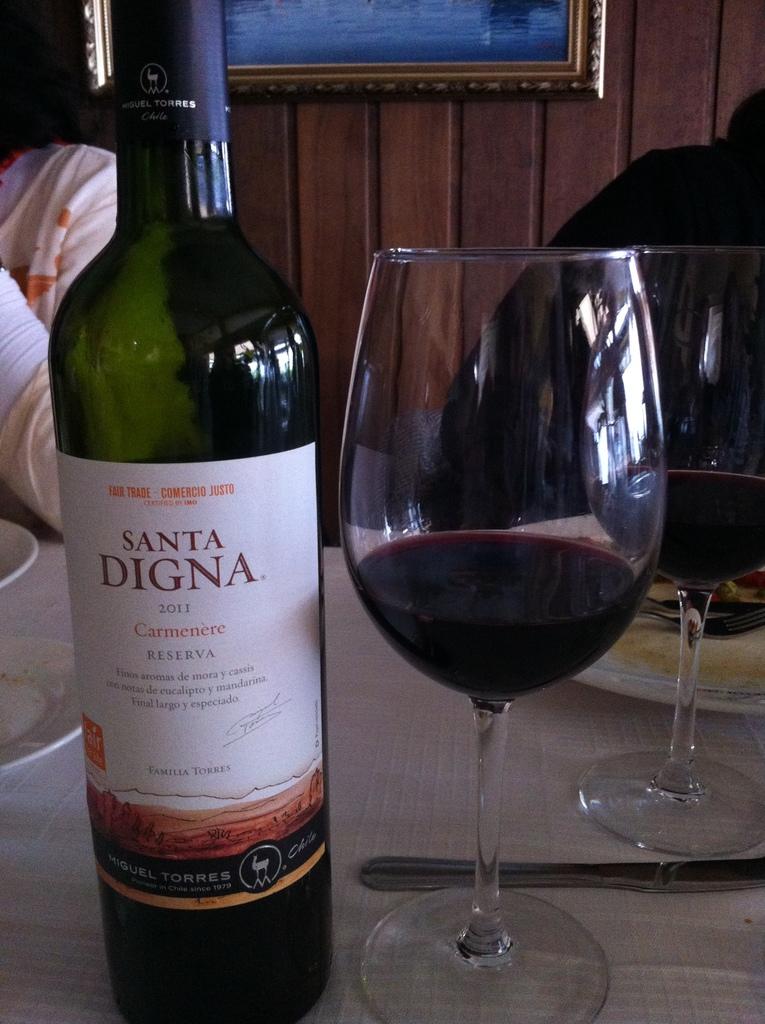What is the name of the winery?
Offer a terse response. Santa digna. What is the year on this wine?
Provide a succinct answer. 2011. 